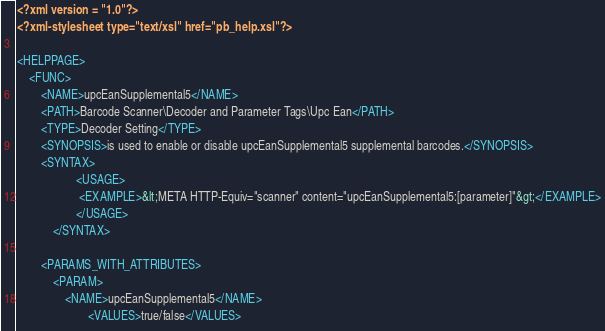Convert code to text. <code><loc_0><loc_0><loc_500><loc_500><_XML_><?xml version = "1.0"?>
<?xml-stylesheet type="text/xsl" href="pb_help.xsl"?>

<HELPPAGE>
	<FUNC>
		<NAME>upcEanSupplemental5</NAME>
		<PATH>Barcode Scanner\Decoder and Parameter Tags\Upc Ean</PATH>
		<TYPE>Decoder Setting</TYPE>
		<SYNOPSIS>is used to enable or disable upcEanSupplemental5 supplemental barcodes.</SYNOPSIS>
		<SYNTAX>
            		<USAGE>
               		 <EXAMPLE>&lt;META HTTP-Equiv="scanner" content="upcEanSupplemental5:[parameter]"&gt;</EXAMPLE>
            		</USAGE>
        	</SYNTAX>

		<PARAMS_WITH_ATTRIBUTES>
			<PARAM>
				<NAME>upcEanSupplemental5</NAME>
                		<VALUES>true/false</VALUES></code> 